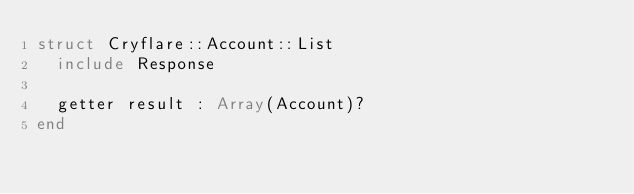<code> <loc_0><loc_0><loc_500><loc_500><_Crystal_>struct Cryflare::Account::List
  include Response

  getter result : Array(Account)?
end
</code> 